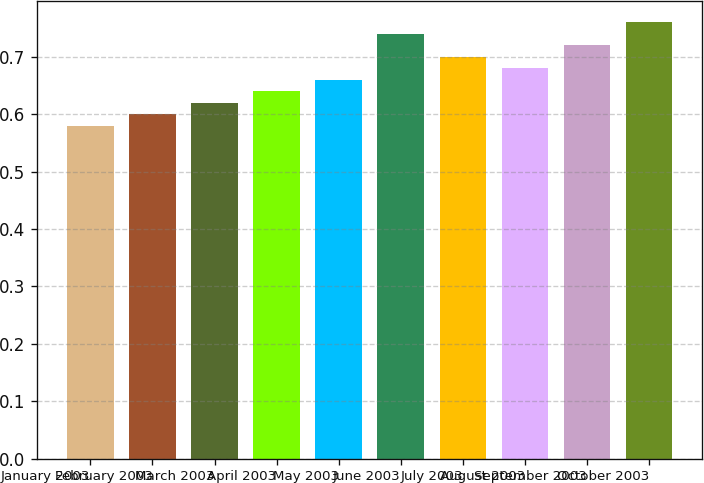<chart> <loc_0><loc_0><loc_500><loc_500><bar_chart><fcel>January 2003<fcel>February 2003<fcel>March 2003<fcel>April 2003<fcel>May 2003<fcel>June 2003<fcel>July 2003<fcel>August 2003<fcel>September 2003<fcel>October 2003<nl><fcel>0.58<fcel>0.6<fcel>0.62<fcel>0.64<fcel>0.66<fcel>0.74<fcel>0.7<fcel>0.68<fcel>0.72<fcel>0.76<nl></chart> 